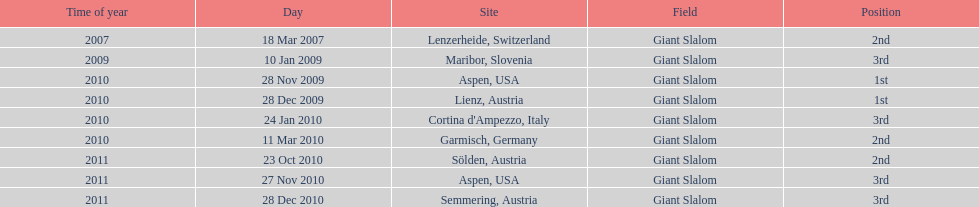Aspen and lienz in 2009 are the only races where this racer got what position? 1st. 